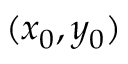<formula> <loc_0><loc_0><loc_500><loc_500>( x _ { 0 } , y _ { 0 } )</formula> 